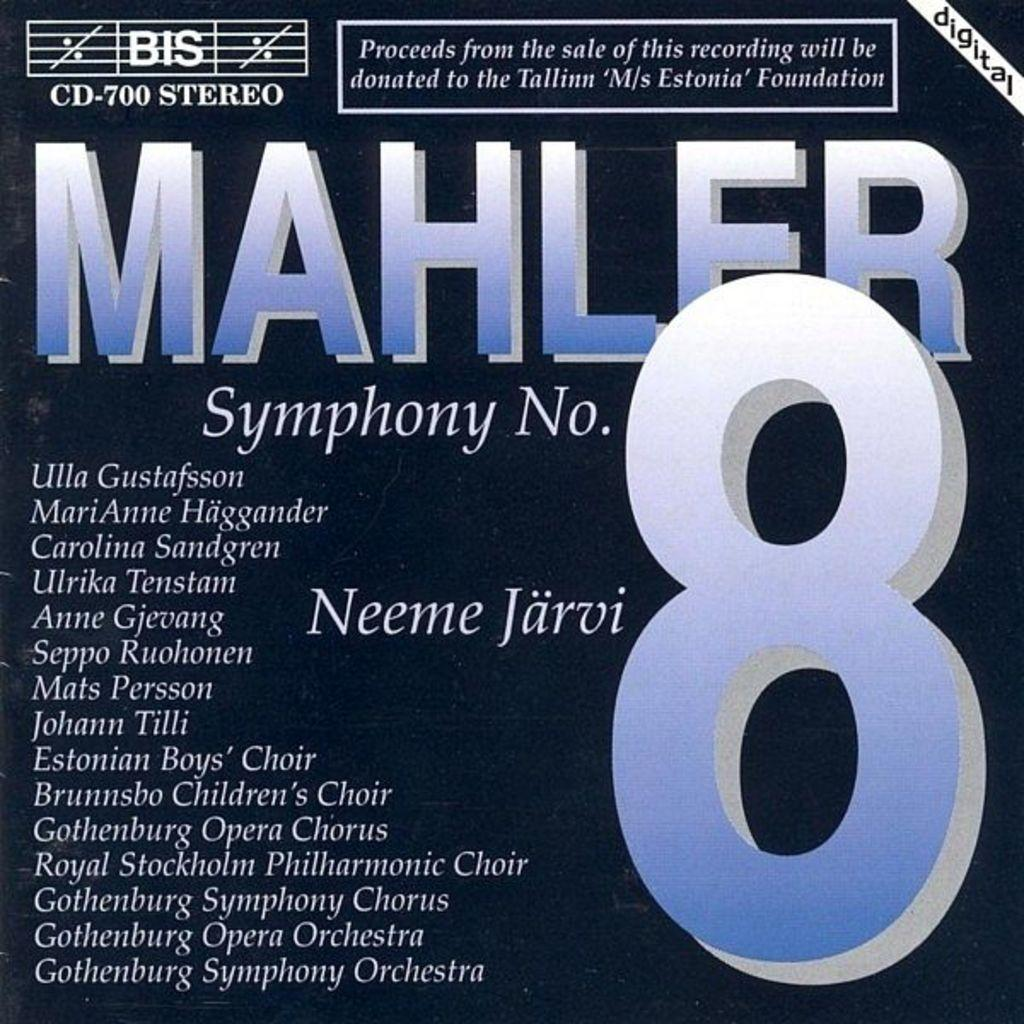<image>
Describe the image concisely. The cover of an album of "Mahler's Symphony No. 8" with blue text is shown featuring Neeme Jarvi among others. 